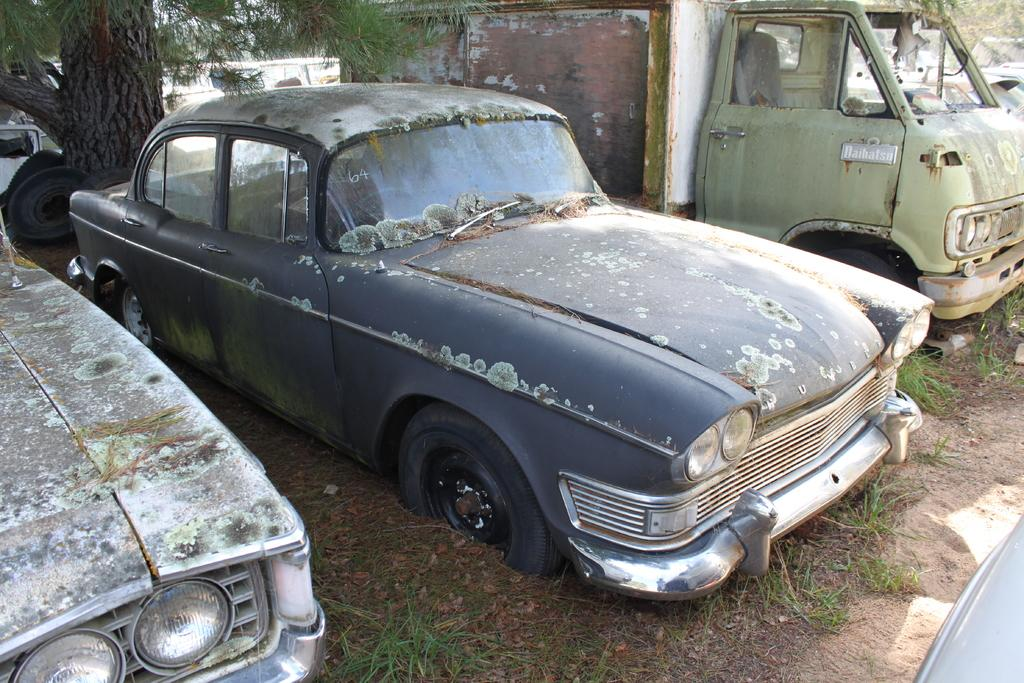What types of objects can be seen in the image? There are vehicles in the image. What can be seen at the bottom of the image? The ground is visible at the bottom of the image. What type of vegetation is present in the image? Grass is present in the image. What additional detail can be observed on the ground? Dry leaves are visible in the image. Where is the tree trunk located in the image? There is a tree trunk on the left side top of the image. What month is it in the image? The month cannot be determined from the image, as there is no information about the time of year or any seasonal indicators present. 